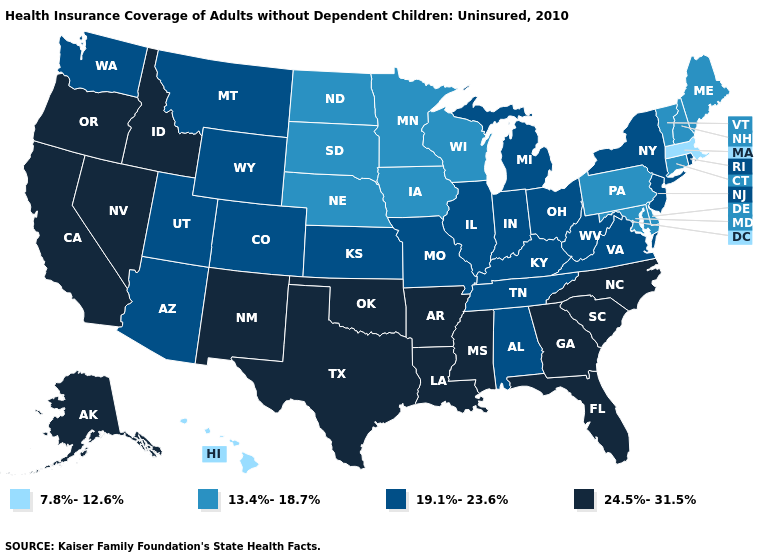What is the value of Hawaii?
Answer briefly. 7.8%-12.6%. Does the map have missing data?
Give a very brief answer. No. What is the value of Texas?
Answer briefly. 24.5%-31.5%. Does Massachusetts have the lowest value in the USA?
Keep it brief. Yes. Does Pennsylvania have the highest value in the Northeast?
Quick response, please. No. How many symbols are there in the legend?
Concise answer only. 4. Which states have the lowest value in the MidWest?
Write a very short answer. Iowa, Minnesota, Nebraska, North Dakota, South Dakota, Wisconsin. Name the states that have a value in the range 24.5%-31.5%?
Concise answer only. Alaska, Arkansas, California, Florida, Georgia, Idaho, Louisiana, Mississippi, Nevada, New Mexico, North Carolina, Oklahoma, Oregon, South Carolina, Texas. Name the states that have a value in the range 24.5%-31.5%?
Answer briefly. Alaska, Arkansas, California, Florida, Georgia, Idaho, Louisiana, Mississippi, Nevada, New Mexico, North Carolina, Oklahoma, Oregon, South Carolina, Texas. Name the states that have a value in the range 13.4%-18.7%?
Answer briefly. Connecticut, Delaware, Iowa, Maine, Maryland, Minnesota, Nebraska, New Hampshire, North Dakota, Pennsylvania, South Dakota, Vermont, Wisconsin. Does Tennessee have the lowest value in the USA?
Quick response, please. No. What is the highest value in the MidWest ?
Keep it brief. 19.1%-23.6%. Does the map have missing data?
Give a very brief answer. No. Name the states that have a value in the range 7.8%-12.6%?
Concise answer only. Hawaii, Massachusetts. Is the legend a continuous bar?
Quick response, please. No. 